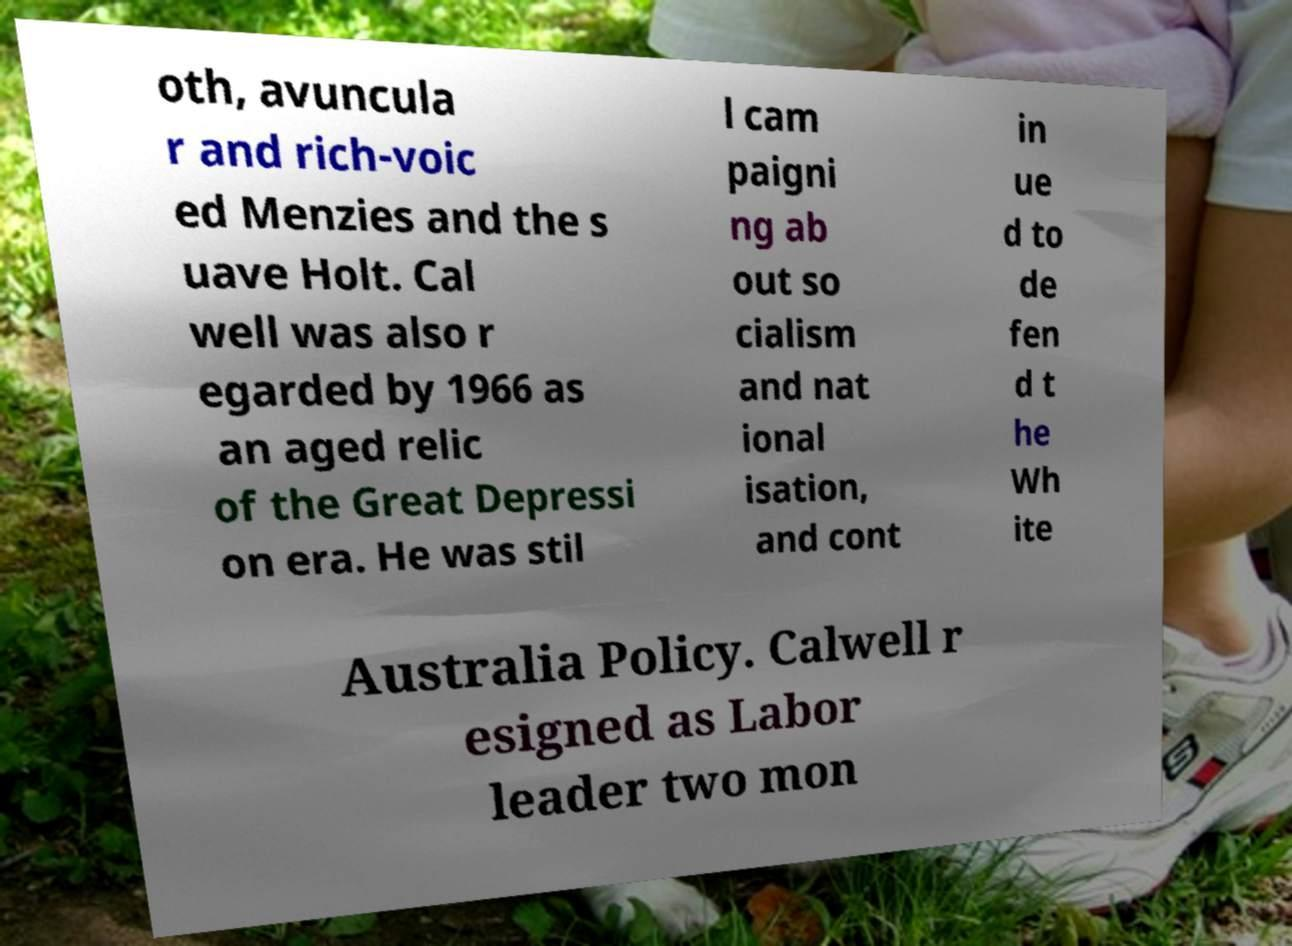Please read and relay the text visible in this image. What does it say? oth, avuncula r and rich-voic ed Menzies and the s uave Holt. Cal well was also r egarded by 1966 as an aged relic of the Great Depressi on era. He was stil l cam paigni ng ab out so cialism and nat ional isation, and cont in ue d to de fen d t he Wh ite Australia Policy. Calwell r esigned as Labor leader two mon 